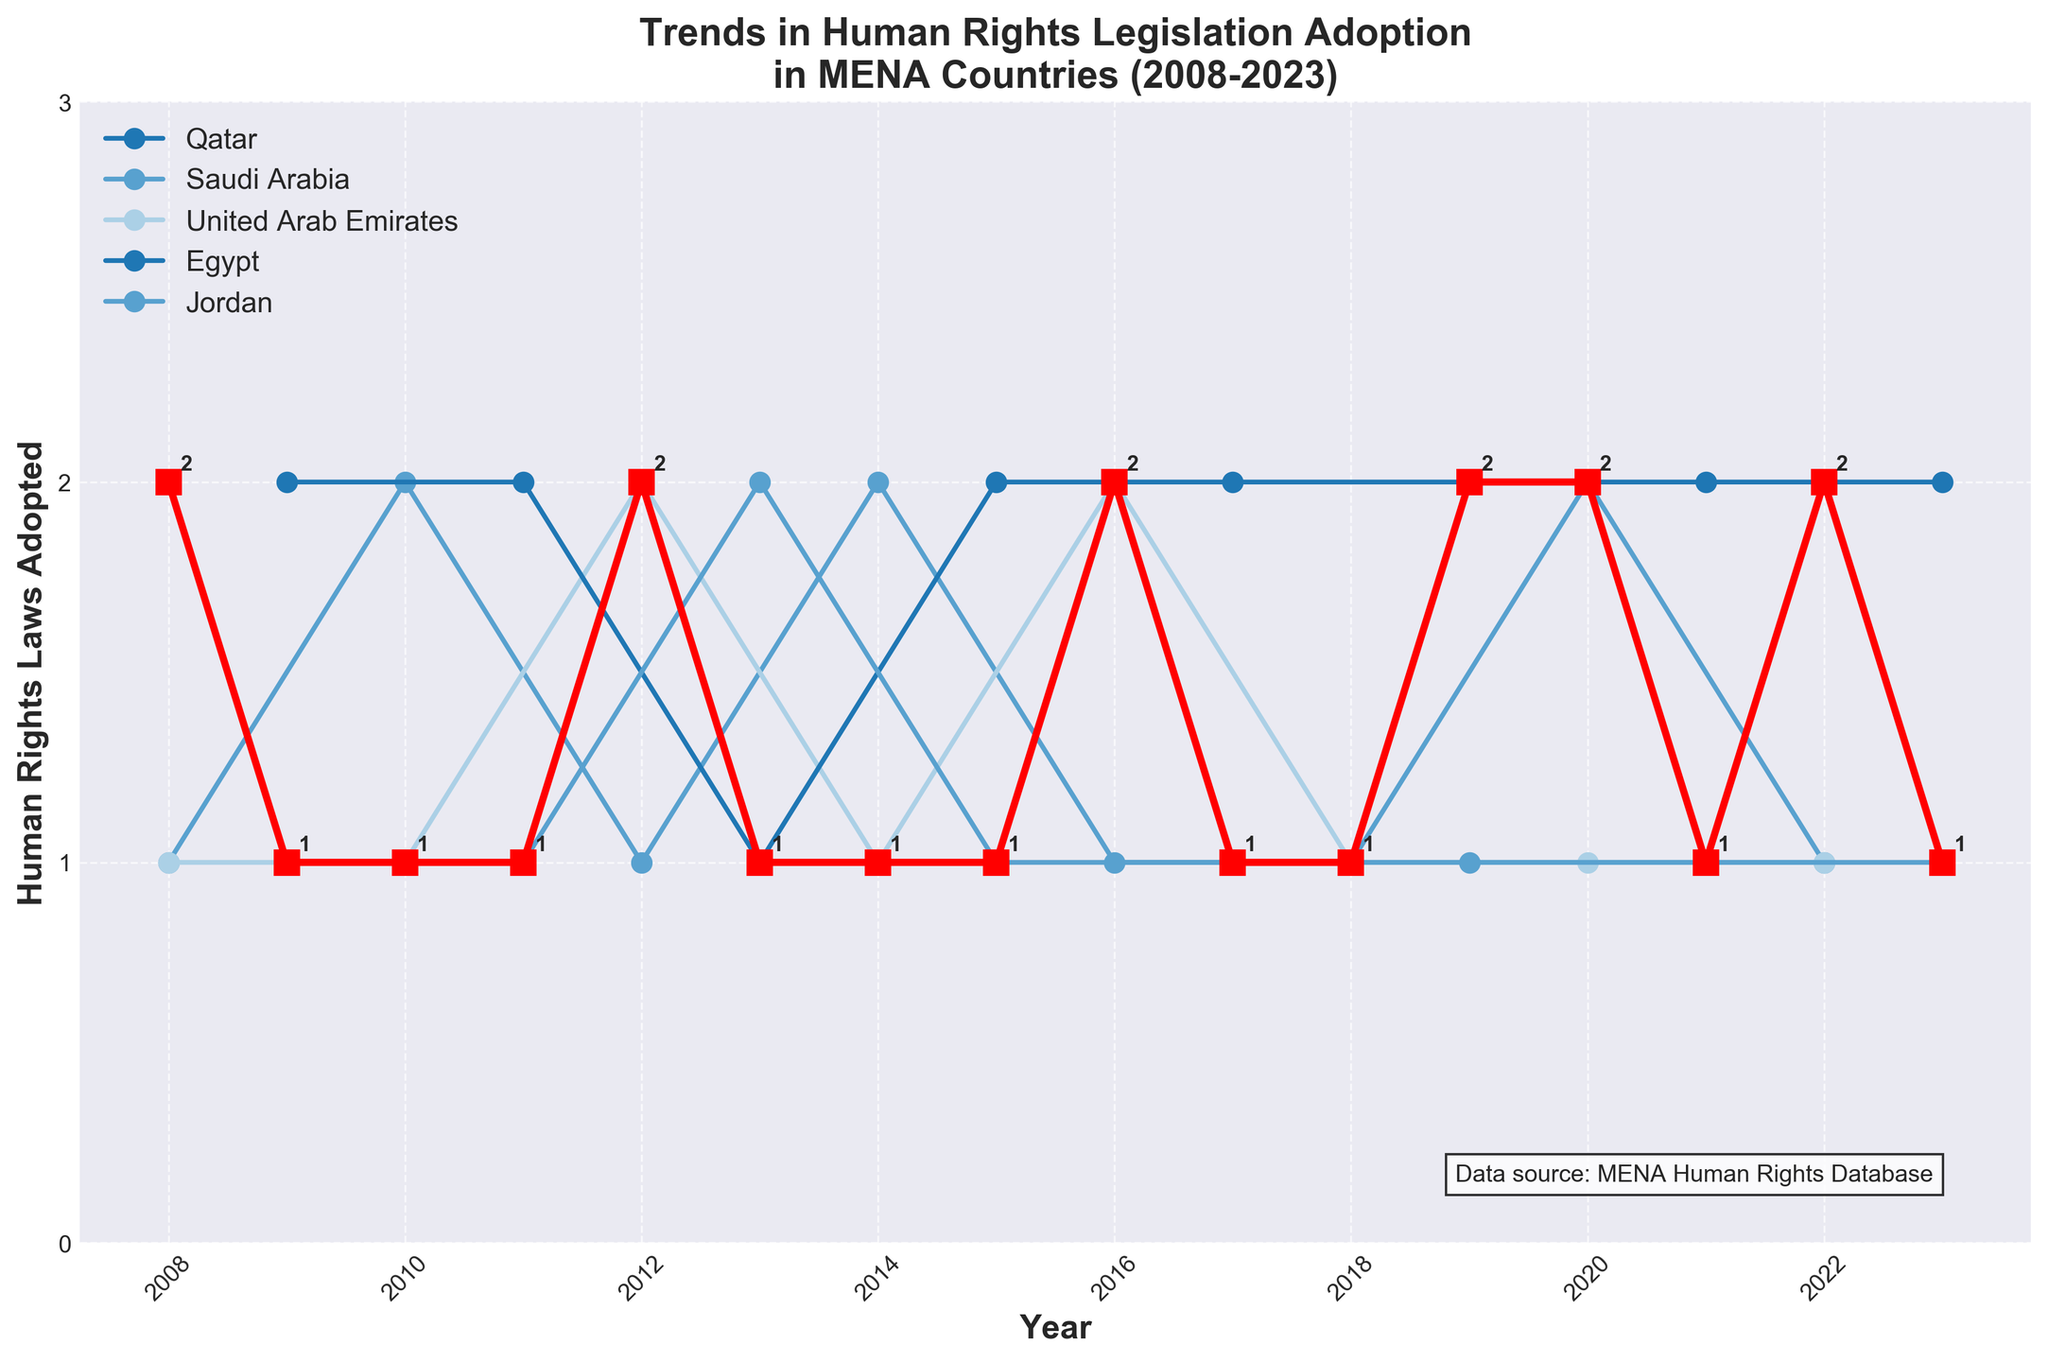What is the title of the plot? The title of the plot is located at the top and reads "Trends in Human Rights Legislation Adoption in MENA Countries (2008-2023)."
Answer: Trends in Human Rights Legislation Adoption in MENA Countries (2008-2023) How many distinct countries are represented in the plot? To find the number of distinct countries, we look at the legend on the plot which labels the countries being compared. There are five distinct countries listed.
Answer: 5 On average, how many human rights laws were adopted by Qatar from 2008 to 2023? First, identify the number of laws adopted by Qatar each year from the chart, sum them up, and then divide by the number of years (16). The values are: 2, 1, 1, 1, 2, 1, 1, 1, 2, 1, 2, 1, 1, 2, 1, 1. Summing these gives 22. Dividing by the number of years (16), we get 22/16 = 1.375.
Answer: 1.375 Which country adopted the most human rights laws in 2011? Look at the year 2011 on the x-axis and identify the highest point on the corresponding vertical line. The highest point is associated with Egypt, with 2 laws.
Answer: Egypt How many times did Saudi Arabia adopt human rights laws equal to or greater than 2 in a year within the given timeframe? Count the number of years where Saudi Arabia's data points are at 2 or higher. These years are 2010 (2), 2014 (2), and 2020 (2). This occurs 3 times.
Answer: 3 Did any country adopt only 1 human right law consistently over multiple consecutive years? Examine each country's trends. Qatar adopted exactly 1 law in consecutive years from 2013 to 2015 (3 years).
Answer: Yes, Qatar from 2013 to 2015 During which years did Qatar adopt exactly 2 human rights laws, and how often did this occur? Identify the years where Qatar’s data points are at 2. These years are 2008, 2012, 2016, 2019, 2020, and 2022. Counting these years, we find it occurred 6 times.
Answer: 2008, 2012, 2016, 2019, 2020, 2022 Which country showed the most variation in the number of human rights laws adopted from year to year, and how can you tell? Examine the patterns for each country, noting the fluctuations year by year. Jordan shows variation, but Egypt records both increases and decreases more prominently, indicating the most variation overall.
Answer: Egypt In what year did both Qatar and the United Arab Emirates adopt the same number of human rights laws, and how many was that? Locate a year where both Qatar and UAE’s lines meet or have the same vertical value. In 2018, both adopted 1 law each.
Answer: 2018, 1 What is the general trend in the number of human rights laws adopted by Qatar from 2008 to 2023? Observing the overall pattern of Qatar’s data points, there is a general alternation but no clear increasing or decreasing trend overall, suggesting variability with slight inclines and declines over periods.
Answer: Variable with no clear overall trend 